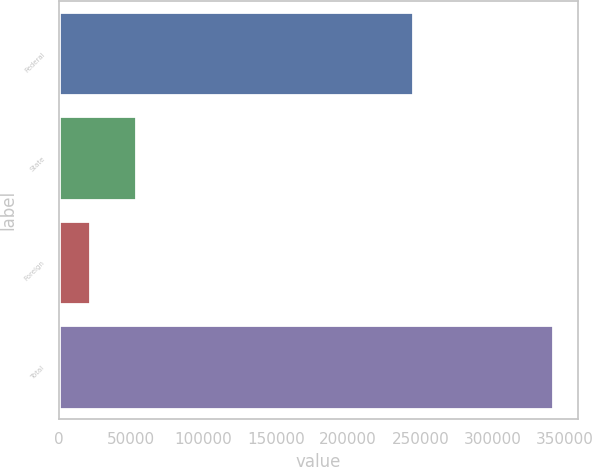Convert chart. <chart><loc_0><loc_0><loc_500><loc_500><bar_chart><fcel>Federal<fcel>State<fcel>Foreign<fcel>Total<nl><fcel>245189<fcel>53232.2<fcel>21138<fcel>342080<nl></chart> 